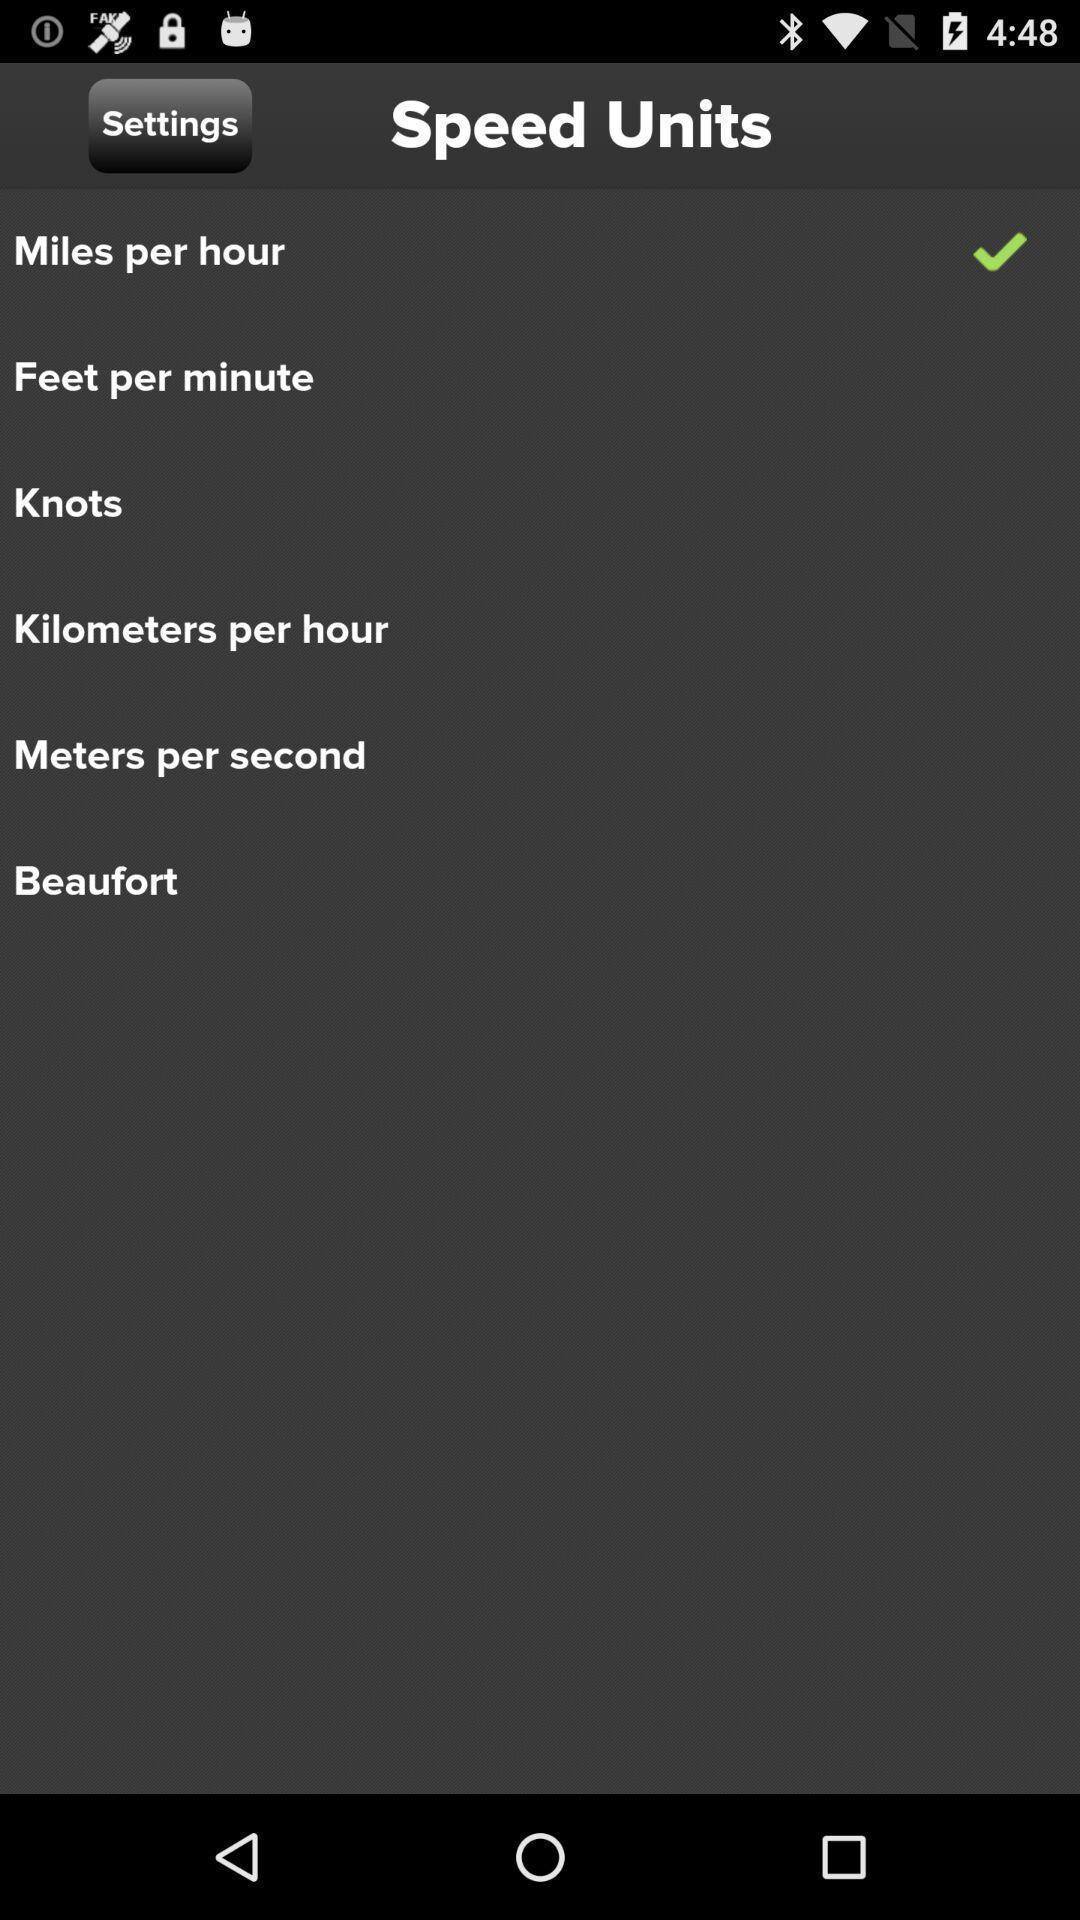Give me a summary of this screen capture. Page shows the different settings of speed units. 